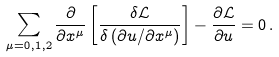<formula> <loc_0><loc_0><loc_500><loc_500>\sum _ { \mu = 0 , 1 , 2 } \frac { \partial } { \partial x ^ { \mu } } \left [ \frac { \delta \mathcal { L } } { \delta \left ( { \partial u } / { \partial x ^ { \mu } } \right ) } \right ] - \frac { \partial \mathcal { L } } { \partial u } = 0 \, .</formula> 